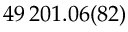<formula> <loc_0><loc_0><loc_500><loc_500>4 9 \, 2 0 1 . 0 6 ( 8 2 )</formula> 